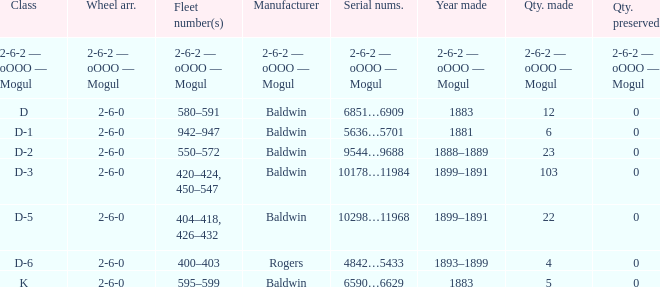What is the wheel arrangement when the year made is 1881? 2-6-0. 